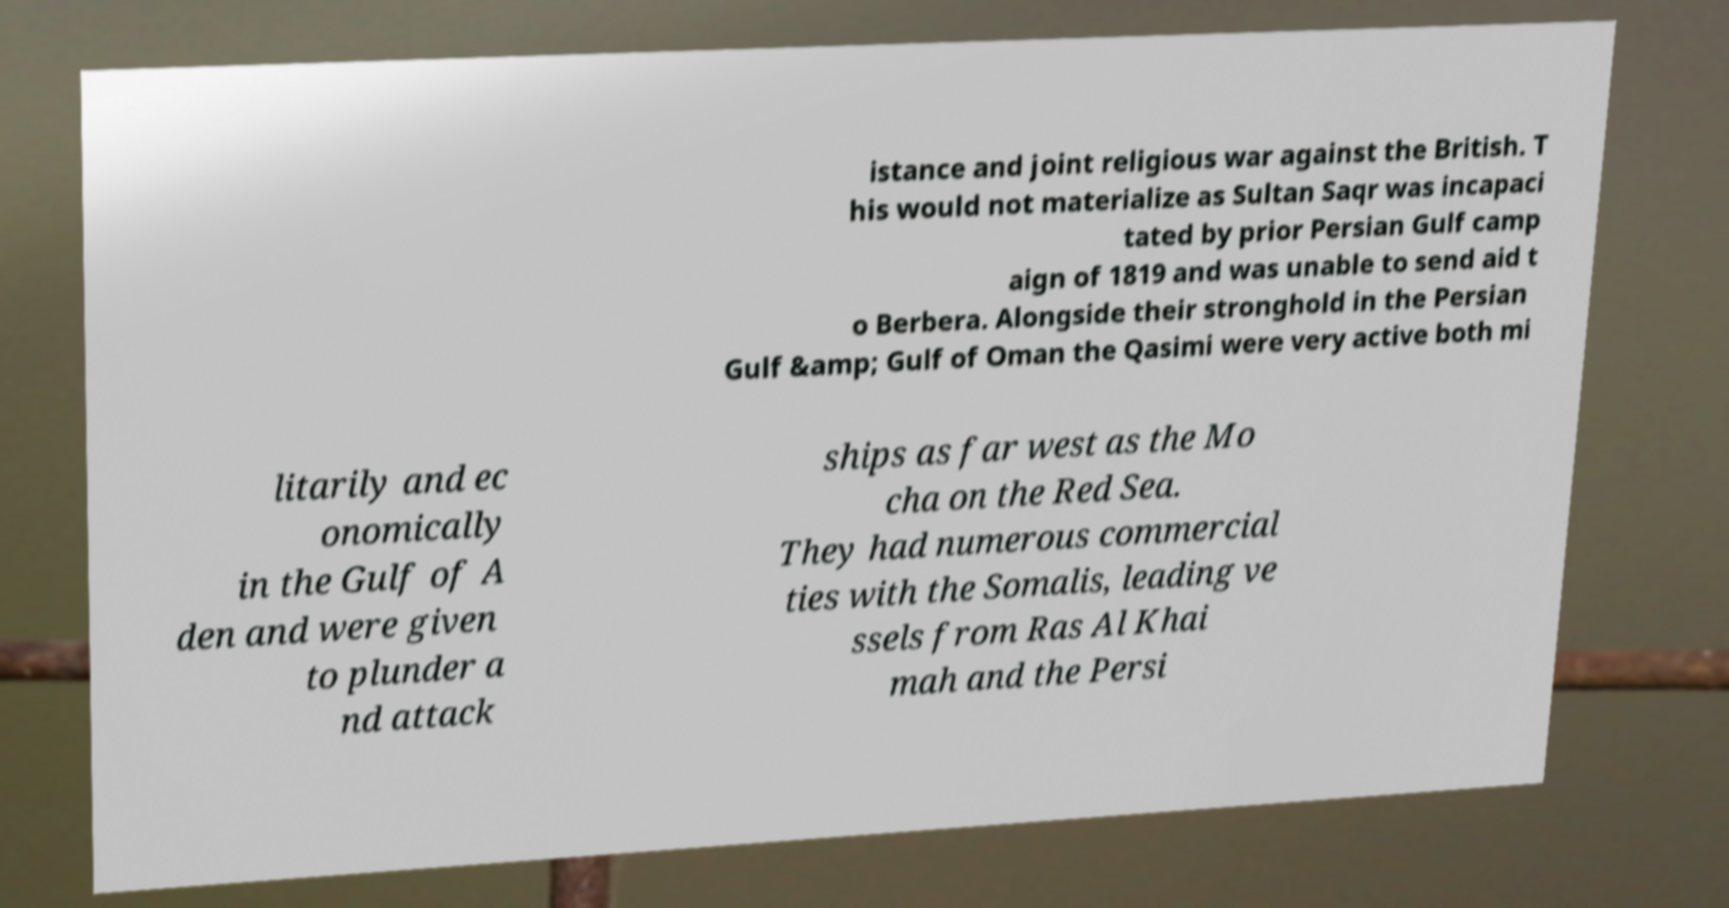Please read and relay the text visible in this image. What does it say? istance and joint religious war against the British. T his would not materialize as Sultan Saqr was incapaci tated by prior Persian Gulf camp aign of 1819 and was unable to send aid t o Berbera. Alongside their stronghold in the Persian Gulf &amp; Gulf of Oman the Qasimi were very active both mi litarily and ec onomically in the Gulf of A den and were given to plunder a nd attack ships as far west as the Mo cha on the Red Sea. They had numerous commercial ties with the Somalis, leading ve ssels from Ras Al Khai mah and the Persi 